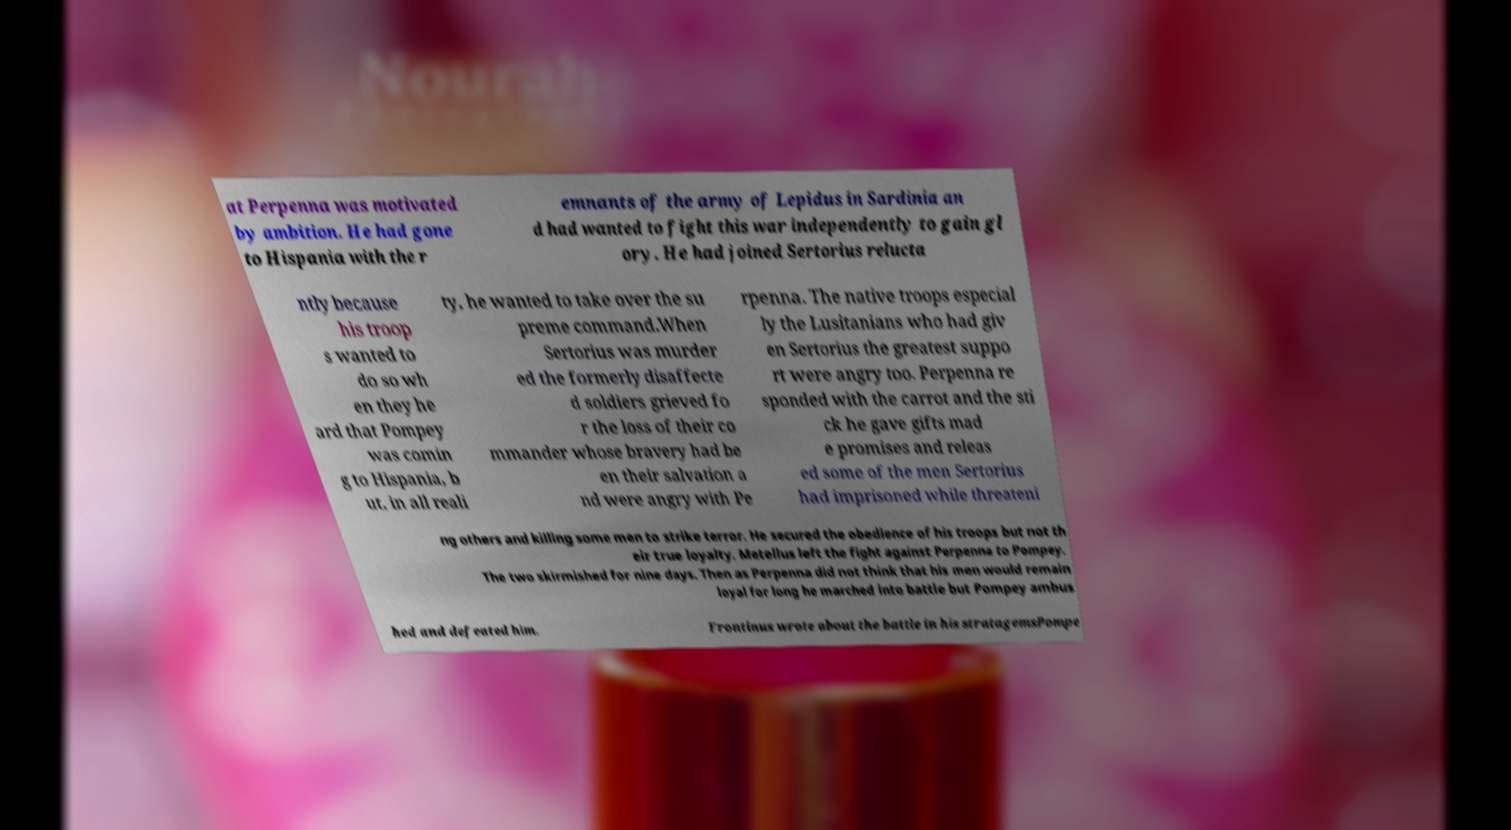Could you assist in decoding the text presented in this image and type it out clearly? at Perpenna was motivated by ambition. He had gone to Hispania with the r emnants of the army of Lepidus in Sardinia an d had wanted to fight this war independently to gain gl ory. He had joined Sertorius relucta ntly because his troop s wanted to do so wh en they he ard that Pompey was comin g to Hispania, b ut, in all reali ty, he wanted to take over the su preme command.When Sertorius was murder ed the formerly disaffecte d soldiers grieved fo r the loss of their co mmander whose bravery had be en their salvation a nd were angry with Pe rpenna. The native troops especial ly the Lusitanians who had giv en Sertorius the greatest suppo rt were angry too. Perpenna re sponded with the carrot and the sti ck he gave gifts mad e promises and releas ed some of the men Sertorius had imprisoned while threateni ng others and killing some men to strike terror. He secured the obedience of his troops but not th eir true loyalty. Metellus left the fight against Perpenna to Pompey. The two skirmished for nine days. Then as Perpenna did not think that his men would remain loyal for long he marched into battle but Pompey ambus hed and defeated him. Frontinus wrote about the battle in his stratagemsPompe 